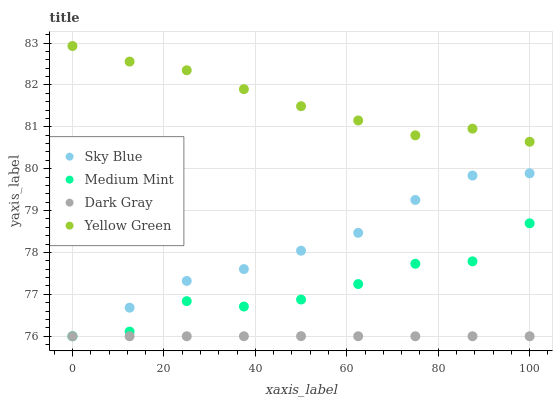Does Dark Gray have the minimum area under the curve?
Answer yes or no. Yes. Does Yellow Green have the maximum area under the curve?
Answer yes or no. Yes. Does Sky Blue have the minimum area under the curve?
Answer yes or no. No. Does Sky Blue have the maximum area under the curve?
Answer yes or no. No. Is Dark Gray the smoothest?
Answer yes or no. Yes. Is Medium Mint the roughest?
Answer yes or no. Yes. Is Sky Blue the smoothest?
Answer yes or no. No. Is Sky Blue the roughest?
Answer yes or no. No. Does Medium Mint have the lowest value?
Answer yes or no. Yes. Does Yellow Green have the lowest value?
Answer yes or no. No. Does Yellow Green have the highest value?
Answer yes or no. Yes. Does Sky Blue have the highest value?
Answer yes or no. No. Is Dark Gray less than Yellow Green?
Answer yes or no. Yes. Is Yellow Green greater than Dark Gray?
Answer yes or no. Yes. Does Dark Gray intersect Sky Blue?
Answer yes or no. Yes. Is Dark Gray less than Sky Blue?
Answer yes or no. No. Is Dark Gray greater than Sky Blue?
Answer yes or no. No. Does Dark Gray intersect Yellow Green?
Answer yes or no. No. 